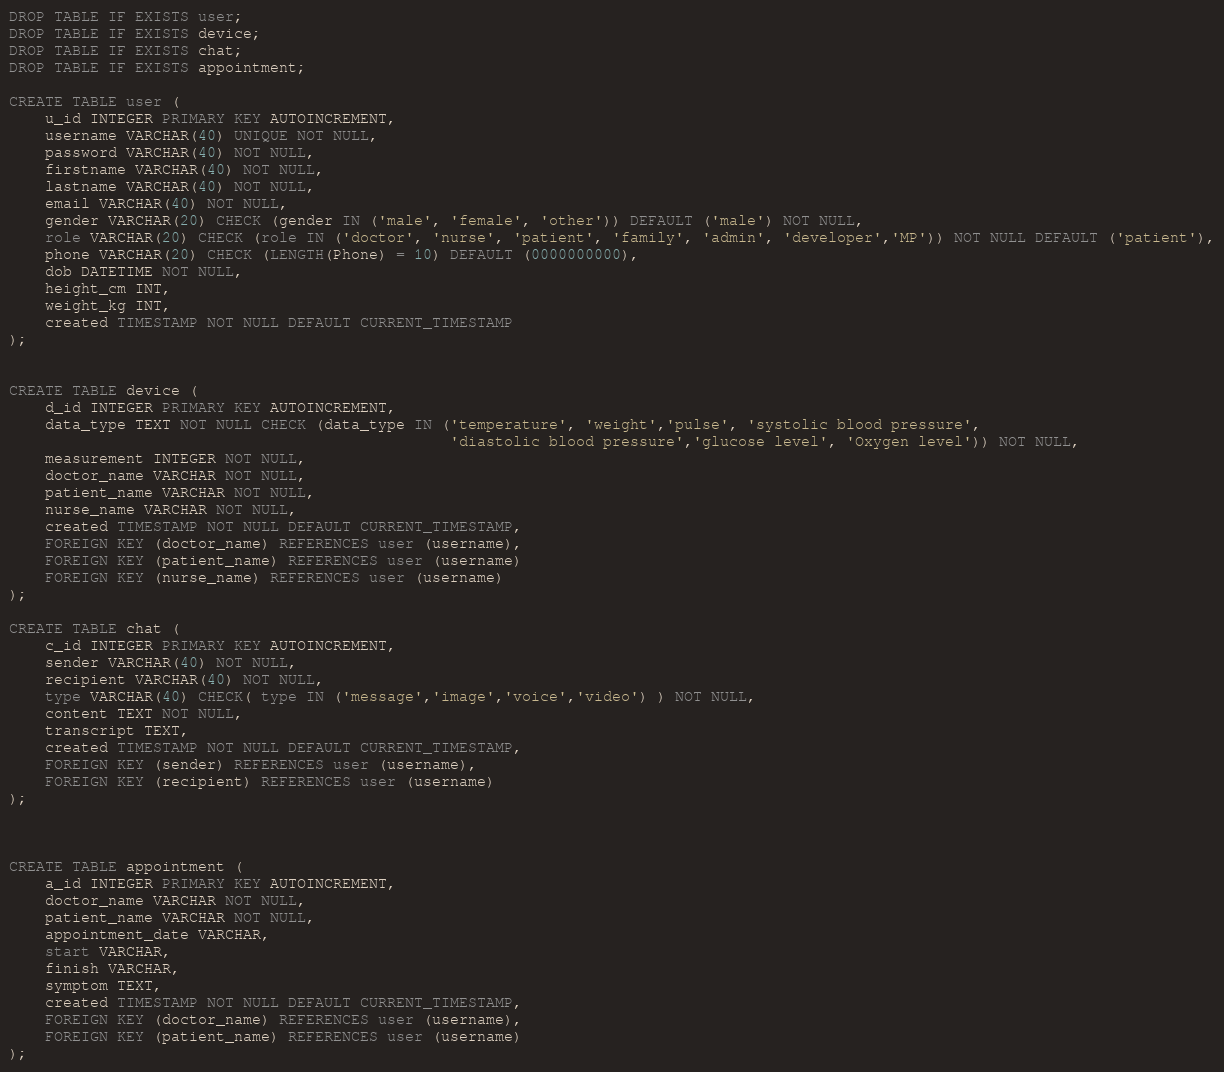<code> <loc_0><loc_0><loc_500><loc_500><_SQL_>DROP TABLE IF EXISTS user;
DROP TABLE IF EXISTS device;
DROP TABLE IF EXISTS chat;
DROP TABLE IF EXISTS appointment;

CREATE TABLE user (
    u_id INTEGER PRIMARY KEY AUTOINCREMENT,
    username VARCHAR(40) UNIQUE NOT NULL,
    password VARCHAR(40) NOT NULL,
    firstname VARCHAR(40) NOT NULL, 
    lastname VARCHAR(40) NOT NULL,
    email VARCHAR(40) NOT NULL,
    gender VARCHAR(20) CHECK (gender IN ('male', 'female', 'other')) DEFAULT ('male') NOT NULL,
    role VARCHAR(20) CHECK (role IN ('doctor', 'nurse', 'patient', 'family', 'admin', 'developer','MP')) NOT NULL DEFAULT ('patient'),
    phone VARCHAR(20) CHECK (LENGTH(Phone) = 10) DEFAULT (0000000000), 
    dob DATETIME NOT NULL, 
    height_cm INT, 
    weight_kg INT,
    created TIMESTAMP NOT NULL DEFAULT CURRENT_TIMESTAMP
);


CREATE TABLE device (
    d_id INTEGER PRIMARY KEY AUTOINCREMENT,
    data_type TEXT NOT NULL CHECK (data_type IN ('temperature', 'weight','pulse', 'systolic blood pressure',
                                                 'diastolic blood pressure','glucose level', 'Oxygen level')) NOT NULL,
    measurement INTEGER NOT NULL,
    doctor_name VARCHAR NOT NULL,
    patient_name VARCHAR NOT NULL,
    nurse_name VARCHAR NOT NULL,
    created TIMESTAMP NOT NULL DEFAULT CURRENT_TIMESTAMP,
    FOREIGN KEY (doctor_name) REFERENCES user (username),
    FOREIGN KEY (patient_name) REFERENCES user (username)
    FOREIGN KEY (nurse_name) REFERENCES user (username)
);

CREATE TABLE chat (
    c_id INTEGER PRIMARY KEY AUTOINCREMENT,
    sender VARCHAR(40) NOT NULL,
    recipient VARCHAR(40) NOT NULL,
    type VARCHAR(40) CHECK( type IN ('message','image','voice','video') ) NOT NULL,
    content TEXT NOT NULL,
    transcript TEXT,
    created TIMESTAMP NOT NULL DEFAULT CURRENT_TIMESTAMP,
    FOREIGN KEY (sender) REFERENCES user (username),
    FOREIGN KEY (recipient) REFERENCES user (username)
);



CREATE TABLE appointment (
    a_id INTEGER PRIMARY KEY AUTOINCREMENT,
    doctor_name VARCHAR NOT NULL,
    patient_name VARCHAR NOT NULL,
    appointment_date VARCHAR,
    start VARCHAR,
    finish VARCHAR,
    symptom TEXT,
    created TIMESTAMP NOT NULL DEFAULT CURRENT_TIMESTAMP,
    FOREIGN KEY (doctor_name) REFERENCES user (username),
    FOREIGN KEY (patient_name) REFERENCES user (username)
);</code> 